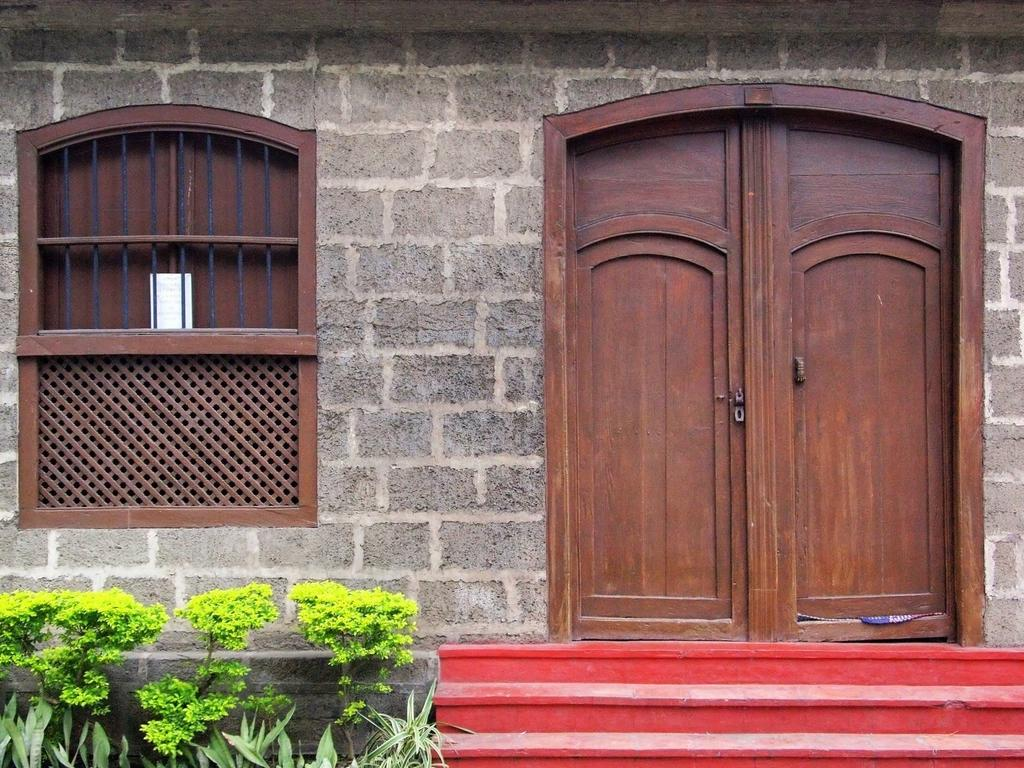What type of structure is present in the image? There is a wall in the image. What features can be seen on the wall? The wall has doors and a window. What else is visible in the image besides the wall? There are plants and stairs in the image. What type of haircut is the wall giving in the image? The wall is not giving a haircut in the image, as it is a structure and not a person. 